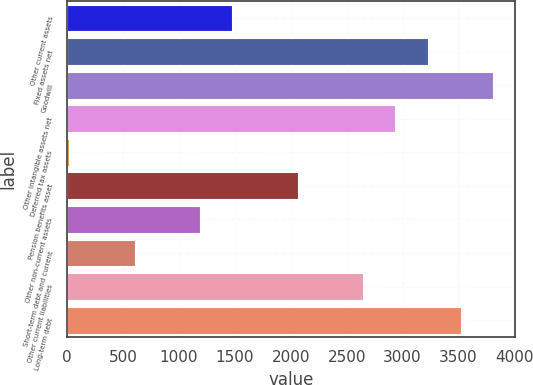<chart> <loc_0><loc_0><loc_500><loc_500><bar_chart><fcel>Other current assets<fcel>Fixed assets net<fcel>Goodwill<fcel>Other intangible assets net<fcel>Deferred tax assets<fcel>Pension benefits asset<fcel>Other non-current assets<fcel>Short-term debt and current<fcel>Other current liabilities<fcel>Long-term debt<nl><fcel>1478<fcel>3228.8<fcel>3812.4<fcel>2937<fcel>19<fcel>2061.6<fcel>1186.2<fcel>602.6<fcel>2645.2<fcel>3520.6<nl></chart> 